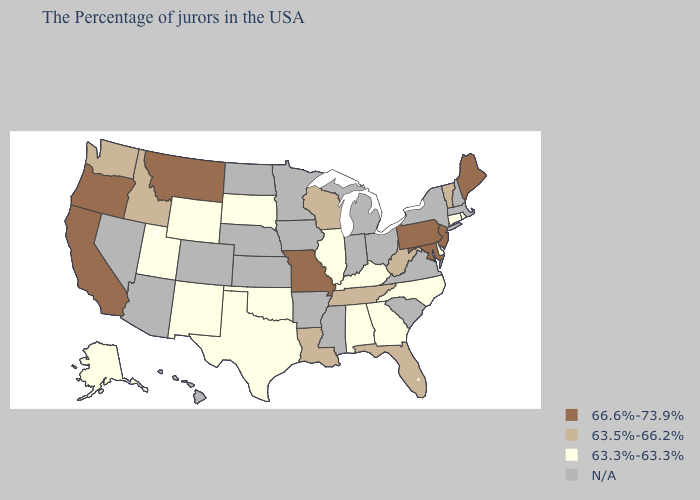Does Oregon have the highest value in the USA?
Quick response, please. Yes. What is the highest value in the USA?
Answer briefly. 66.6%-73.9%. What is the highest value in the USA?
Answer briefly. 66.6%-73.9%. What is the highest value in the South ?
Answer briefly. 66.6%-73.9%. What is the lowest value in the USA?
Be succinct. 63.3%-63.3%. Name the states that have a value in the range 63.3%-63.3%?
Be succinct. Rhode Island, Connecticut, Delaware, North Carolina, Georgia, Kentucky, Alabama, Illinois, Oklahoma, Texas, South Dakota, Wyoming, New Mexico, Utah, Alaska. What is the value of Indiana?
Give a very brief answer. N/A. What is the value of Arkansas?
Give a very brief answer. N/A. What is the lowest value in states that border New Hampshire?
Give a very brief answer. 63.5%-66.2%. What is the lowest value in the USA?
Short answer required. 63.3%-63.3%. What is the lowest value in the USA?
Keep it brief. 63.3%-63.3%. What is the value of Kansas?
Be succinct. N/A. Which states have the highest value in the USA?
Quick response, please. Maine, New Jersey, Maryland, Pennsylvania, Missouri, Montana, California, Oregon. Does the first symbol in the legend represent the smallest category?
Write a very short answer. No. 